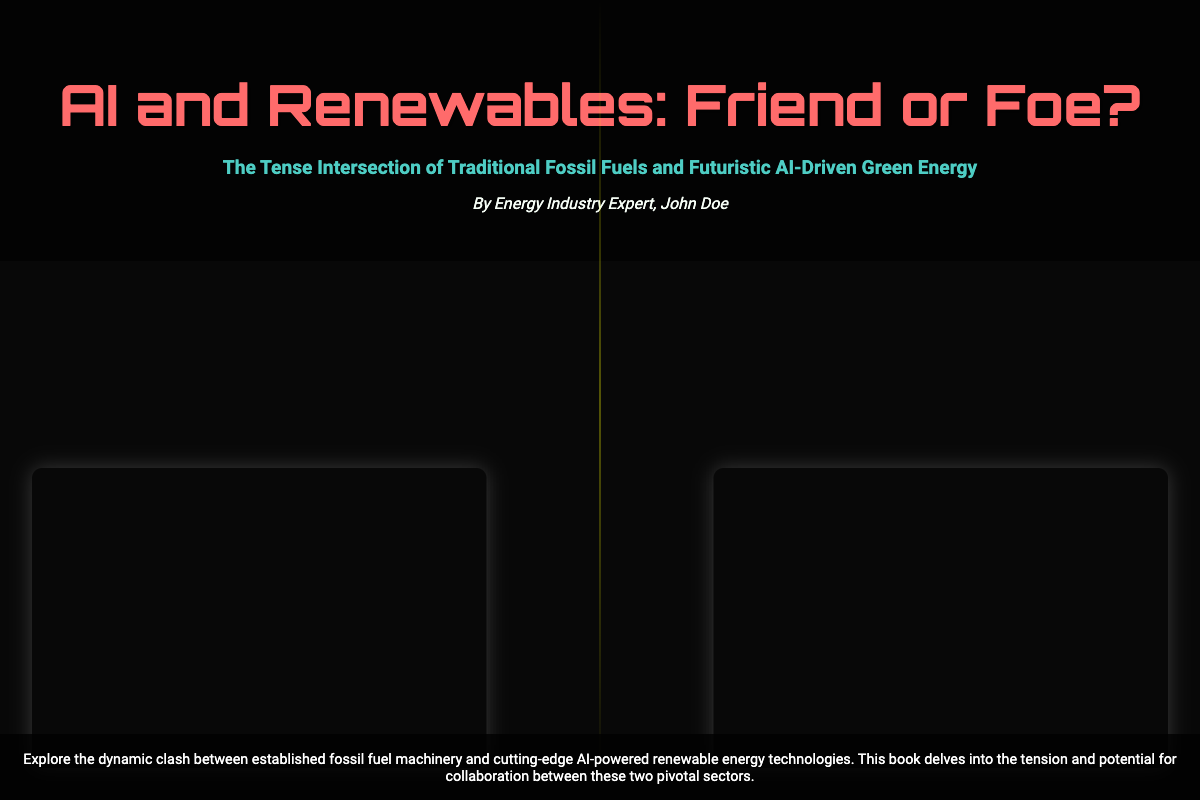What is the title of the book? The title of the book is prominently displayed at the top of the cover.
Answer: AI and Renewables: Friend or Foe? Who is the author of the book? The author is mentioned below the title section on the cover.
Answer: John Doe What is the main theme of the book? The theme is summarized in the subtitle provided on the cover.
Answer: The Tense Intersection of Traditional Fossil Fuels and Futuristic AI-Driven Green Energy What two industries are primarily depicted on the cover? The cover shows images representing both industries, highlighted in the content section.
Answer: Fossil fuels and renewable energy What color is used for the title text? The color of the title text is specifically mentioned in the design description.
Answer: Red What type of effect is shown between the two main images? The visual effect representing the conflict between the two industries is indicated in the cover design elements.
Answer: Clash effect What backgrounds are used for the oil rig and AI turbine images? The backgrounds refer to the specific images used for the elements of the cover.
Answer: Oil rig and AI wind turbine images What type of atmosphere does the cover create with its color scheme? The color scheme contributes to the overall vibe of the book cover.
Answer: Dark and futuristic What animation effect is indicated for the clash element? The animation effect is mentioned in the style section of the document.
Answer: Pulse animation 